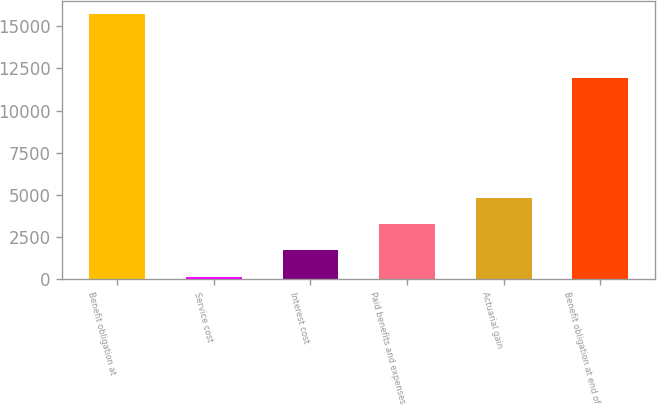<chart> <loc_0><loc_0><loc_500><loc_500><bar_chart><fcel>Benefit obligation at<fcel>Service cost<fcel>Interest cost<fcel>Paid benefits and expenses<fcel>Actuarial gain<fcel>Benefit obligation at end of<nl><fcel>15713<fcel>160<fcel>1715.3<fcel>3270.6<fcel>4825.9<fcel>11930<nl></chart> 